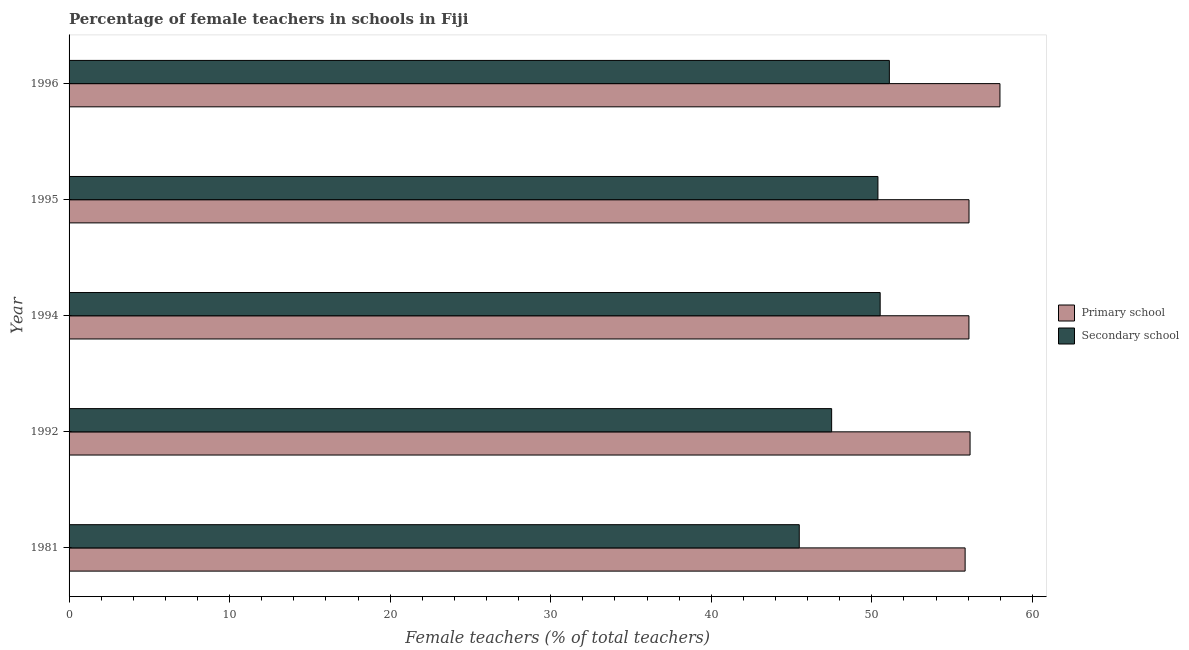How many different coloured bars are there?
Your answer should be very brief. 2. How many groups of bars are there?
Your response must be concise. 5. Are the number of bars per tick equal to the number of legend labels?
Ensure brevity in your answer.  Yes. How many bars are there on the 4th tick from the top?
Make the answer very short. 2. How many bars are there on the 5th tick from the bottom?
Ensure brevity in your answer.  2. What is the label of the 3rd group of bars from the top?
Offer a very short reply. 1994. What is the percentage of female teachers in primary schools in 1992?
Keep it short and to the point. 56.12. Across all years, what is the maximum percentage of female teachers in primary schools?
Ensure brevity in your answer.  57.98. Across all years, what is the minimum percentage of female teachers in primary schools?
Make the answer very short. 55.81. In which year was the percentage of female teachers in primary schools minimum?
Provide a short and direct response. 1981. What is the total percentage of female teachers in primary schools in the graph?
Make the answer very short. 281.99. What is the difference between the percentage of female teachers in secondary schools in 1995 and that in 1996?
Make the answer very short. -0.71. What is the difference between the percentage of female teachers in secondary schools in 1995 and the percentage of female teachers in primary schools in 1981?
Your response must be concise. -5.43. What is the average percentage of female teachers in secondary schools per year?
Your response must be concise. 48.99. In the year 1996, what is the difference between the percentage of female teachers in primary schools and percentage of female teachers in secondary schools?
Your answer should be compact. 6.89. What is the ratio of the percentage of female teachers in secondary schools in 1981 to that in 1996?
Offer a terse response. 0.89. Is the difference between the percentage of female teachers in primary schools in 1992 and 1996 greater than the difference between the percentage of female teachers in secondary schools in 1992 and 1996?
Ensure brevity in your answer.  Yes. What is the difference between the highest and the second highest percentage of female teachers in primary schools?
Keep it short and to the point. 1.86. What is the difference between the highest and the lowest percentage of female teachers in primary schools?
Your answer should be very brief. 2.17. In how many years, is the percentage of female teachers in primary schools greater than the average percentage of female teachers in primary schools taken over all years?
Give a very brief answer. 1. What does the 2nd bar from the top in 1992 represents?
Provide a succinct answer. Primary school. What does the 1st bar from the bottom in 1996 represents?
Provide a succinct answer. Primary school. Are all the bars in the graph horizontal?
Keep it short and to the point. Yes. What is the difference between two consecutive major ticks on the X-axis?
Offer a very short reply. 10. Are the values on the major ticks of X-axis written in scientific E-notation?
Offer a very short reply. No. Does the graph contain grids?
Make the answer very short. No. How many legend labels are there?
Ensure brevity in your answer.  2. How are the legend labels stacked?
Your response must be concise. Vertical. What is the title of the graph?
Your response must be concise. Percentage of female teachers in schools in Fiji. Does "Electricity and heat production" appear as one of the legend labels in the graph?
Provide a succinct answer. No. What is the label or title of the X-axis?
Your answer should be very brief. Female teachers (% of total teachers). What is the label or title of the Y-axis?
Provide a succinct answer. Year. What is the Female teachers (% of total teachers) in Primary school in 1981?
Keep it short and to the point. 55.81. What is the Female teachers (% of total teachers) of Secondary school in 1981?
Your answer should be very brief. 45.48. What is the Female teachers (% of total teachers) in Primary school in 1992?
Your answer should be very brief. 56.12. What is the Female teachers (% of total teachers) of Secondary school in 1992?
Your answer should be compact. 47.49. What is the Female teachers (% of total teachers) of Primary school in 1994?
Offer a terse response. 56.05. What is the Female teachers (% of total teachers) in Secondary school in 1994?
Offer a terse response. 50.52. What is the Female teachers (% of total teachers) in Primary school in 1995?
Ensure brevity in your answer.  56.05. What is the Female teachers (% of total teachers) in Secondary school in 1995?
Provide a short and direct response. 50.38. What is the Female teachers (% of total teachers) in Primary school in 1996?
Offer a terse response. 57.98. What is the Female teachers (% of total teachers) in Secondary school in 1996?
Your answer should be very brief. 51.09. Across all years, what is the maximum Female teachers (% of total teachers) of Primary school?
Provide a short and direct response. 57.98. Across all years, what is the maximum Female teachers (% of total teachers) of Secondary school?
Keep it short and to the point. 51.09. Across all years, what is the minimum Female teachers (% of total teachers) of Primary school?
Offer a terse response. 55.81. Across all years, what is the minimum Female teachers (% of total teachers) in Secondary school?
Your answer should be compact. 45.48. What is the total Female teachers (% of total teachers) in Primary school in the graph?
Provide a short and direct response. 281.99. What is the total Female teachers (% of total teachers) of Secondary school in the graph?
Your answer should be very brief. 244.95. What is the difference between the Female teachers (% of total teachers) in Primary school in 1981 and that in 1992?
Ensure brevity in your answer.  -0.31. What is the difference between the Female teachers (% of total teachers) in Secondary school in 1981 and that in 1992?
Your response must be concise. -2.02. What is the difference between the Female teachers (% of total teachers) of Primary school in 1981 and that in 1994?
Your answer should be compact. -0.24. What is the difference between the Female teachers (% of total teachers) in Secondary school in 1981 and that in 1994?
Your answer should be very brief. -5.04. What is the difference between the Female teachers (% of total teachers) of Primary school in 1981 and that in 1995?
Give a very brief answer. -0.24. What is the difference between the Female teachers (% of total teachers) in Secondary school in 1981 and that in 1995?
Your answer should be very brief. -4.9. What is the difference between the Female teachers (% of total teachers) of Primary school in 1981 and that in 1996?
Your answer should be very brief. -2.17. What is the difference between the Female teachers (% of total teachers) of Secondary school in 1981 and that in 1996?
Your answer should be compact. -5.61. What is the difference between the Female teachers (% of total teachers) of Primary school in 1992 and that in 1994?
Offer a very short reply. 0.07. What is the difference between the Female teachers (% of total teachers) in Secondary school in 1992 and that in 1994?
Ensure brevity in your answer.  -3.02. What is the difference between the Female teachers (% of total teachers) of Primary school in 1992 and that in 1995?
Provide a short and direct response. 0.07. What is the difference between the Female teachers (% of total teachers) of Secondary school in 1992 and that in 1995?
Offer a terse response. -2.88. What is the difference between the Female teachers (% of total teachers) in Primary school in 1992 and that in 1996?
Your response must be concise. -1.86. What is the difference between the Female teachers (% of total teachers) in Secondary school in 1992 and that in 1996?
Keep it short and to the point. -3.6. What is the difference between the Female teachers (% of total teachers) of Primary school in 1994 and that in 1995?
Offer a very short reply. -0. What is the difference between the Female teachers (% of total teachers) of Secondary school in 1994 and that in 1995?
Provide a succinct answer. 0.14. What is the difference between the Female teachers (% of total teachers) of Primary school in 1994 and that in 1996?
Offer a very short reply. -1.93. What is the difference between the Female teachers (% of total teachers) in Secondary school in 1994 and that in 1996?
Your response must be concise. -0.57. What is the difference between the Female teachers (% of total teachers) in Primary school in 1995 and that in 1996?
Provide a short and direct response. -1.93. What is the difference between the Female teachers (% of total teachers) in Secondary school in 1995 and that in 1996?
Your answer should be compact. -0.71. What is the difference between the Female teachers (% of total teachers) of Primary school in 1981 and the Female teachers (% of total teachers) of Secondary school in 1992?
Provide a succinct answer. 8.31. What is the difference between the Female teachers (% of total teachers) in Primary school in 1981 and the Female teachers (% of total teachers) in Secondary school in 1994?
Offer a terse response. 5.29. What is the difference between the Female teachers (% of total teachers) in Primary school in 1981 and the Female teachers (% of total teachers) in Secondary school in 1995?
Provide a short and direct response. 5.43. What is the difference between the Female teachers (% of total teachers) of Primary school in 1981 and the Female teachers (% of total teachers) of Secondary school in 1996?
Provide a succinct answer. 4.72. What is the difference between the Female teachers (% of total teachers) in Primary school in 1992 and the Female teachers (% of total teachers) in Secondary school in 1994?
Offer a terse response. 5.6. What is the difference between the Female teachers (% of total teachers) of Primary school in 1992 and the Female teachers (% of total teachers) of Secondary school in 1995?
Give a very brief answer. 5.74. What is the difference between the Female teachers (% of total teachers) of Primary school in 1992 and the Female teachers (% of total teachers) of Secondary school in 1996?
Your answer should be compact. 5.03. What is the difference between the Female teachers (% of total teachers) in Primary school in 1994 and the Female teachers (% of total teachers) in Secondary school in 1995?
Offer a very short reply. 5.67. What is the difference between the Female teachers (% of total teachers) in Primary school in 1994 and the Female teachers (% of total teachers) in Secondary school in 1996?
Provide a succinct answer. 4.96. What is the difference between the Female teachers (% of total teachers) in Primary school in 1995 and the Female teachers (% of total teachers) in Secondary school in 1996?
Make the answer very short. 4.96. What is the average Female teachers (% of total teachers) of Primary school per year?
Provide a short and direct response. 56.4. What is the average Female teachers (% of total teachers) of Secondary school per year?
Ensure brevity in your answer.  48.99. In the year 1981, what is the difference between the Female teachers (% of total teachers) in Primary school and Female teachers (% of total teachers) in Secondary school?
Keep it short and to the point. 10.33. In the year 1992, what is the difference between the Female teachers (% of total teachers) of Primary school and Female teachers (% of total teachers) of Secondary school?
Offer a terse response. 8.62. In the year 1994, what is the difference between the Female teachers (% of total teachers) in Primary school and Female teachers (% of total teachers) in Secondary school?
Your answer should be compact. 5.53. In the year 1995, what is the difference between the Female teachers (% of total teachers) of Primary school and Female teachers (% of total teachers) of Secondary school?
Your answer should be compact. 5.67. In the year 1996, what is the difference between the Female teachers (% of total teachers) of Primary school and Female teachers (% of total teachers) of Secondary school?
Offer a terse response. 6.89. What is the ratio of the Female teachers (% of total teachers) in Secondary school in 1981 to that in 1992?
Make the answer very short. 0.96. What is the ratio of the Female teachers (% of total teachers) of Primary school in 1981 to that in 1994?
Give a very brief answer. 1. What is the ratio of the Female teachers (% of total teachers) in Secondary school in 1981 to that in 1994?
Make the answer very short. 0.9. What is the ratio of the Female teachers (% of total teachers) of Secondary school in 1981 to that in 1995?
Your answer should be compact. 0.9. What is the ratio of the Female teachers (% of total teachers) in Primary school in 1981 to that in 1996?
Your answer should be very brief. 0.96. What is the ratio of the Female teachers (% of total teachers) of Secondary school in 1981 to that in 1996?
Give a very brief answer. 0.89. What is the ratio of the Female teachers (% of total teachers) of Secondary school in 1992 to that in 1994?
Ensure brevity in your answer.  0.94. What is the ratio of the Female teachers (% of total teachers) of Secondary school in 1992 to that in 1995?
Offer a very short reply. 0.94. What is the ratio of the Female teachers (% of total teachers) in Primary school in 1992 to that in 1996?
Keep it short and to the point. 0.97. What is the ratio of the Female teachers (% of total teachers) of Secondary school in 1992 to that in 1996?
Provide a succinct answer. 0.93. What is the ratio of the Female teachers (% of total teachers) in Primary school in 1994 to that in 1996?
Ensure brevity in your answer.  0.97. What is the ratio of the Female teachers (% of total teachers) in Primary school in 1995 to that in 1996?
Your answer should be very brief. 0.97. What is the ratio of the Female teachers (% of total teachers) in Secondary school in 1995 to that in 1996?
Make the answer very short. 0.99. What is the difference between the highest and the second highest Female teachers (% of total teachers) of Primary school?
Ensure brevity in your answer.  1.86. What is the difference between the highest and the second highest Female teachers (% of total teachers) in Secondary school?
Your answer should be very brief. 0.57. What is the difference between the highest and the lowest Female teachers (% of total teachers) in Primary school?
Make the answer very short. 2.17. What is the difference between the highest and the lowest Female teachers (% of total teachers) in Secondary school?
Keep it short and to the point. 5.61. 